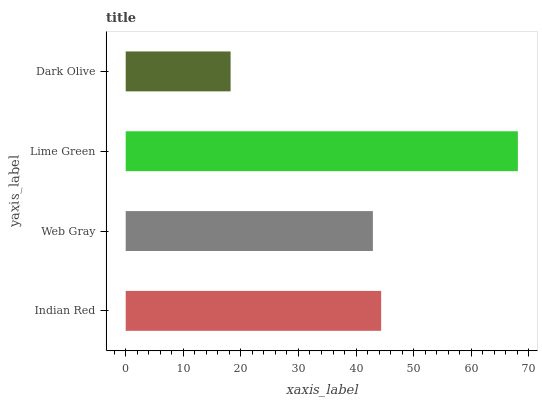Is Dark Olive the minimum?
Answer yes or no. Yes. Is Lime Green the maximum?
Answer yes or no. Yes. Is Web Gray the minimum?
Answer yes or no. No. Is Web Gray the maximum?
Answer yes or no. No. Is Indian Red greater than Web Gray?
Answer yes or no. Yes. Is Web Gray less than Indian Red?
Answer yes or no. Yes. Is Web Gray greater than Indian Red?
Answer yes or no. No. Is Indian Red less than Web Gray?
Answer yes or no. No. Is Indian Red the high median?
Answer yes or no. Yes. Is Web Gray the low median?
Answer yes or no. Yes. Is Web Gray the high median?
Answer yes or no. No. Is Dark Olive the low median?
Answer yes or no. No. 